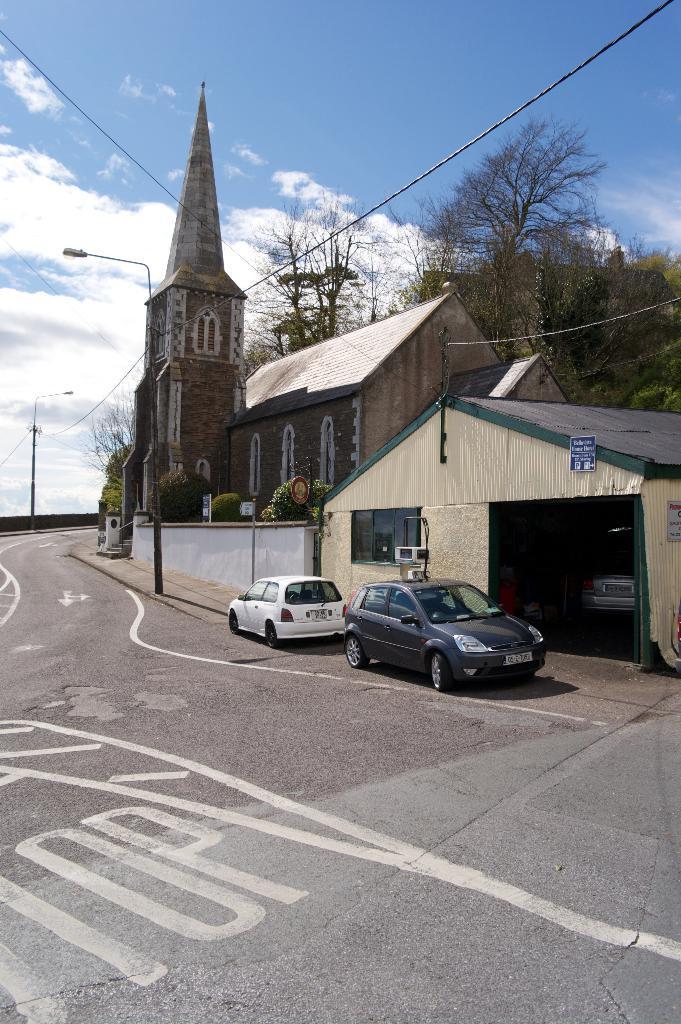Please provide a concise description of this image. In this picture I can see vehicles, there is a house, there is a shed, there are boards, poles, lights, cables, trees, and in the background there is sky. 